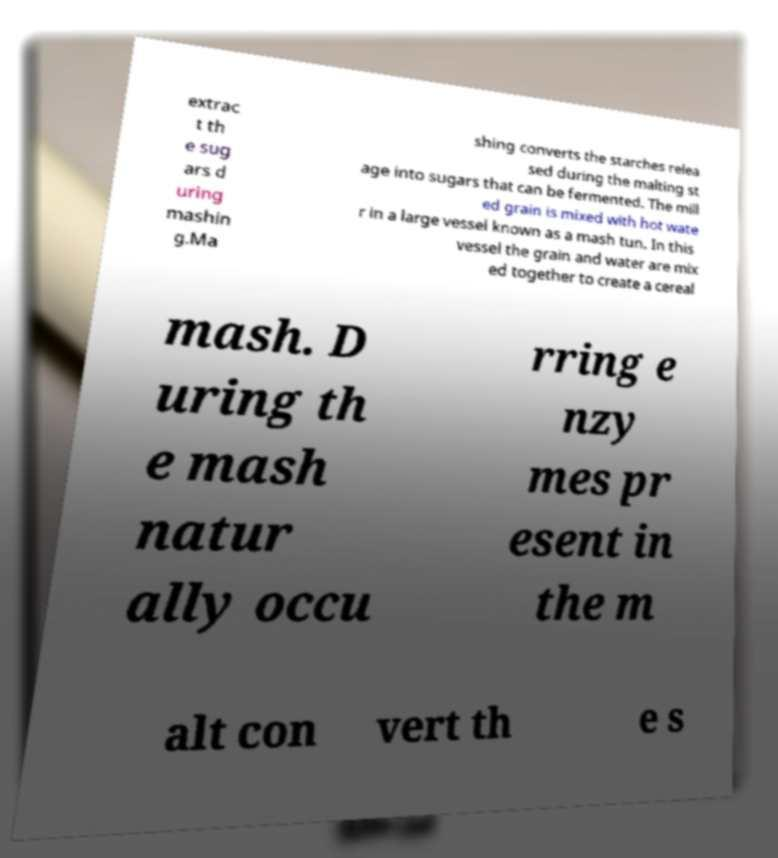Can you accurately transcribe the text from the provided image for me? extrac t th e sug ars d uring mashin g.Ma shing converts the starches relea sed during the malting st age into sugars that can be fermented. The mill ed grain is mixed with hot wate r in a large vessel known as a mash tun. In this vessel the grain and water are mix ed together to create a cereal mash. D uring th e mash natur ally occu rring e nzy mes pr esent in the m alt con vert th e s 